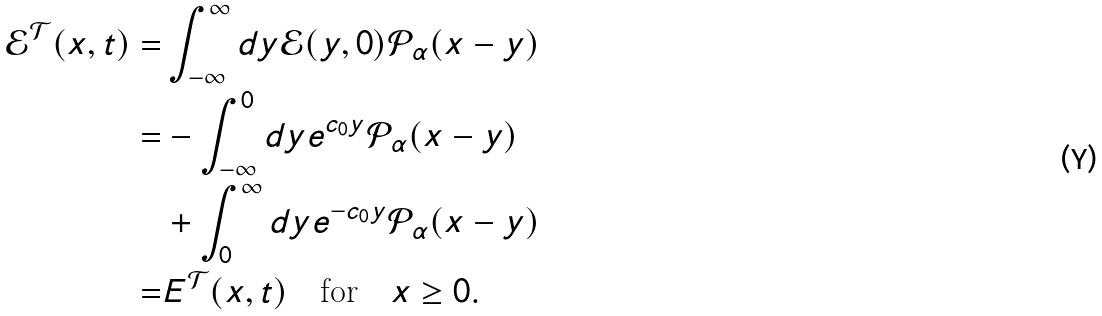<formula> <loc_0><loc_0><loc_500><loc_500>\mathcal { E } ^ { \mathcal { T } } ( x , t ) = & \int _ { - \infty } ^ { \infty } d y \mathcal { E } ( y , 0 ) \mathcal { P } _ { \alpha } ( x - y ) \\ = & - \int _ { - \infty } ^ { 0 } d y e ^ { c _ { 0 } y } \mathcal { P } _ { \alpha } ( x - y ) \\ & + \int _ { 0 } ^ { \infty } d y e ^ { - c _ { 0 } y } \mathcal { P } _ { \alpha } ( x - y ) \\ = & E ^ { \mathcal { T } } ( x , t ) \quad \text {for} \quad x \geq 0 .</formula> 